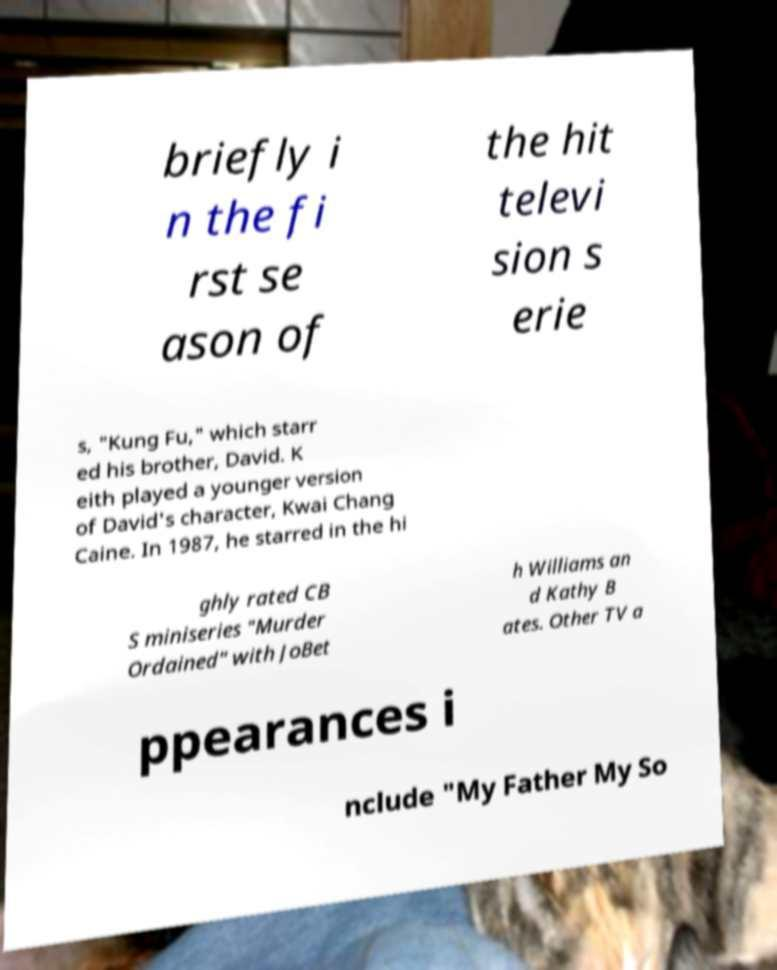Please read and relay the text visible in this image. What does it say? briefly i n the fi rst se ason of the hit televi sion s erie s, "Kung Fu," which starr ed his brother, David. K eith played a younger version of David's character, Kwai Chang Caine. In 1987, he starred in the hi ghly rated CB S miniseries "Murder Ordained" with JoBet h Williams an d Kathy B ates. Other TV a ppearances i nclude "My Father My So 